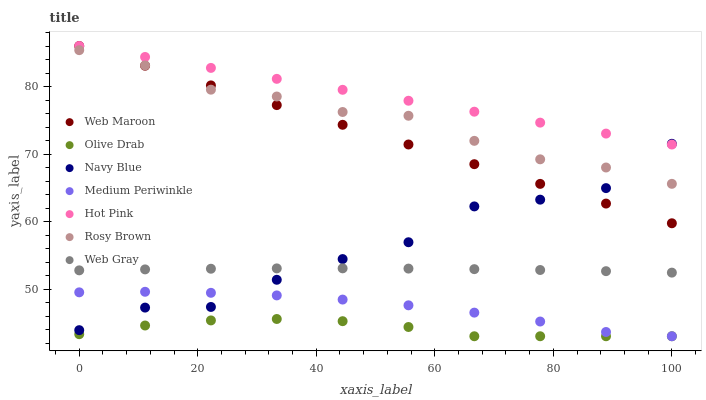Does Olive Drab have the minimum area under the curve?
Answer yes or no. Yes. Does Hot Pink have the maximum area under the curve?
Answer yes or no. Yes. Does Medium Periwinkle have the minimum area under the curve?
Answer yes or no. No. Does Medium Periwinkle have the maximum area under the curve?
Answer yes or no. No. Is Web Maroon the smoothest?
Answer yes or no. Yes. Is Navy Blue the roughest?
Answer yes or no. Yes. Is Medium Periwinkle the smoothest?
Answer yes or no. No. Is Medium Periwinkle the roughest?
Answer yes or no. No. Does Medium Periwinkle have the lowest value?
Answer yes or no. Yes. Does Navy Blue have the lowest value?
Answer yes or no. No. Does Web Maroon have the highest value?
Answer yes or no. Yes. Does Medium Periwinkle have the highest value?
Answer yes or no. No. Is Medium Periwinkle less than Hot Pink?
Answer yes or no. Yes. Is Hot Pink greater than Olive Drab?
Answer yes or no. Yes. Does Web Maroon intersect Rosy Brown?
Answer yes or no. Yes. Is Web Maroon less than Rosy Brown?
Answer yes or no. No. Is Web Maroon greater than Rosy Brown?
Answer yes or no. No. Does Medium Periwinkle intersect Hot Pink?
Answer yes or no. No. 